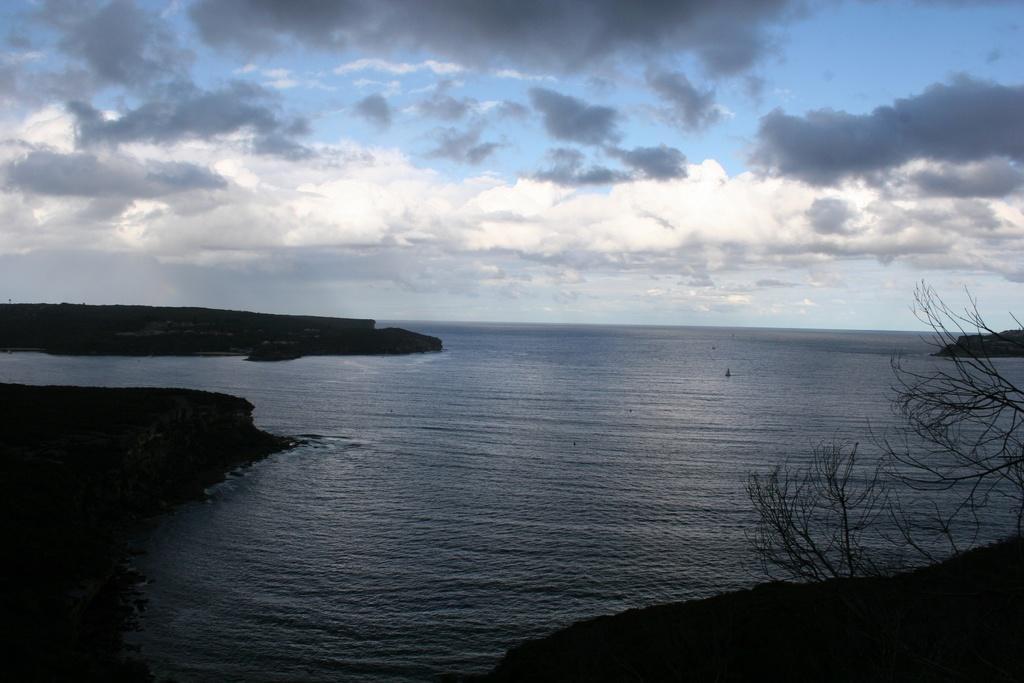In one or two sentences, can you explain what this image depicts? In this image in the front there are dry plant. In the center there is water and on the left side there are objects which are black in colour and the sky is cloudy. 